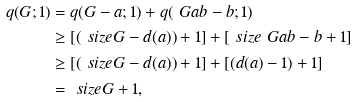<formula> <loc_0><loc_0><loc_500><loc_500>q ( G ; 1 ) & = q ( G - a ; 1 ) + q ( \ G a b - b ; 1 ) \\ & \geq [ ( \ s i z e { G } - d ( a ) ) + 1 ] + [ \ s i z e { \ G a b - b } + 1 ] \\ & \geq [ ( \ s i z e { G } - d ( a ) ) + 1 ] + [ ( d ( a ) - 1 ) + 1 ] \\ & = \ s i z e { G } + 1 ,</formula> 